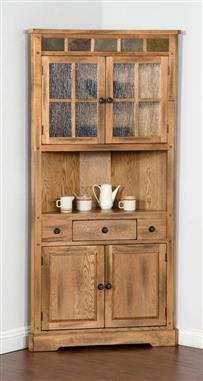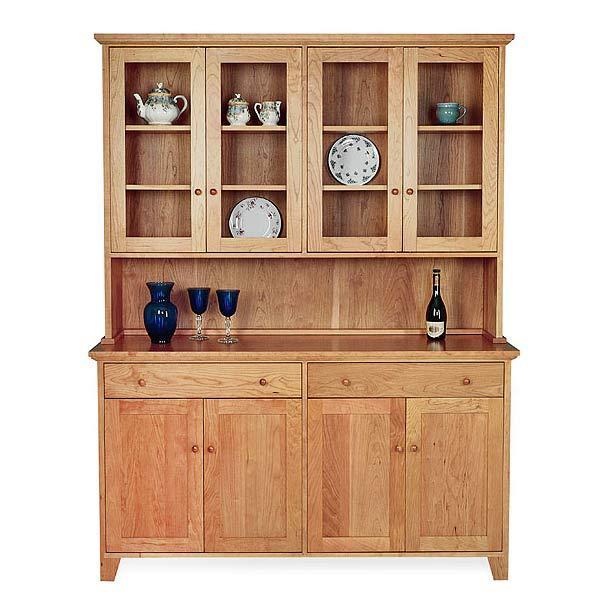The first image is the image on the left, the second image is the image on the right. Given the left and right images, does the statement "Both of the cabinets depicted have flat tops and some type of feet." hold true? Answer yes or no. Yes. 